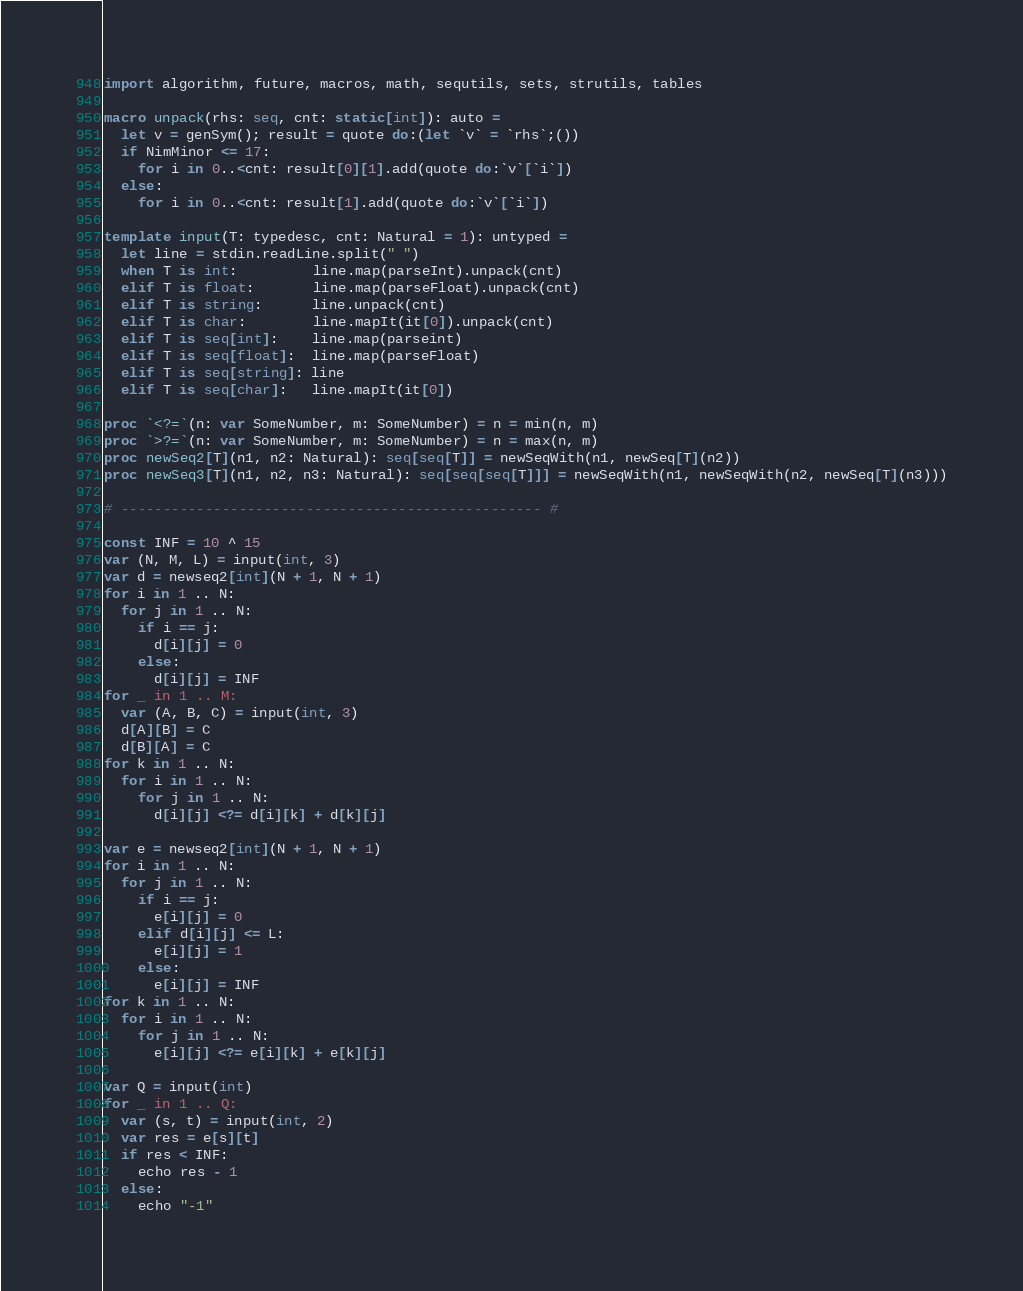<code> <loc_0><loc_0><loc_500><loc_500><_Nim_>import algorithm, future, macros, math, sequtils, sets, strutils, tables

macro unpack(rhs: seq, cnt: static[int]): auto =
  let v = genSym(); result = quote do:(let `v` = `rhs`;())
  if NimMinor <= 17:
    for i in 0..<cnt: result[0][1].add(quote do:`v`[`i`])
  else:
    for i in 0..<cnt: result[1].add(quote do:`v`[`i`])

template input(T: typedesc, cnt: Natural = 1): untyped =
  let line = stdin.readLine.split(" ")
  when T is int:         line.map(parseInt).unpack(cnt)
  elif T is float:       line.map(parseFloat).unpack(cnt)
  elif T is string:      line.unpack(cnt)
  elif T is char:        line.mapIt(it[0]).unpack(cnt)
  elif T is seq[int]:    line.map(parseint)
  elif T is seq[float]:  line.map(parseFloat)
  elif T is seq[string]: line
  elif T is seq[char]:   line.mapIt(it[0])

proc `<?=`(n: var SomeNumber, m: SomeNumber) = n = min(n, m)
proc `>?=`(n: var SomeNumber, m: SomeNumber) = n = max(n, m)
proc newSeq2[T](n1, n2: Natural): seq[seq[T]] = newSeqWith(n1, newSeq[T](n2))
proc newSeq3[T](n1, n2, n3: Natural): seq[seq[seq[T]]] = newSeqWith(n1, newSeqWith(n2, newSeq[T](n3)))

# -------------------------------------------------- #

const INF = 10 ^ 15
var (N, M, L) = input(int, 3)
var d = newseq2[int](N + 1, N + 1)
for i in 1 .. N:
  for j in 1 .. N:
    if i == j:
      d[i][j] = 0
    else:
      d[i][j] = INF
for _ in 1 .. M:
  var (A, B, C) = input(int, 3)
  d[A][B] = C
  d[B][A] = C
for k in 1 .. N:
  for i in 1 .. N:
    for j in 1 .. N:
      d[i][j] <?= d[i][k] + d[k][j]

var e = newseq2[int](N + 1, N + 1)
for i in 1 .. N:
  for j in 1 .. N:
    if i == j:
      e[i][j] = 0
    elif d[i][j] <= L:
      e[i][j] = 1
    else:
      e[i][j] = INF
for k in 1 .. N:
  for i in 1 .. N:
    for j in 1 .. N:
      e[i][j] <?= e[i][k] + e[k][j]

var Q = input(int)
for _ in 1 .. Q:
  var (s, t) = input(int, 2)
  var res = e[s][t]
  if res < INF:
    echo res - 1
  else:
    echo "-1"</code> 